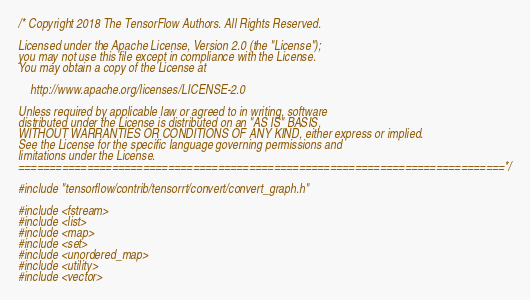Convert code to text. <code><loc_0><loc_0><loc_500><loc_500><_C++_>/* Copyright 2018 The TensorFlow Authors. All Rights Reserved.

Licensed under the Apache License, Version 2.0 (the "License");
you may not use this file except in compliance with the License.
You may obtain a copy of the License at

    http://www.apache.org/licenses/LICENSE-2.0

Unless required by applicable law or agreed to in writing, software
distributed under the License is distributed on an "AS IS" BASIS,
WITHOUT WARRANTIES OR CONDITIONS OF ANY KIND, either express or implied.
See the License for the specific language governing permissions and
limitations under the License.
==============================================================================*/

#include "tensorflow/contrib/tensorrt/convert/convert_graph.h"

#include <fstream>
#include <list>
#include <map>
#include <set>
#include <unordered_map>
#include <utility>
#include <vector>
</code> 